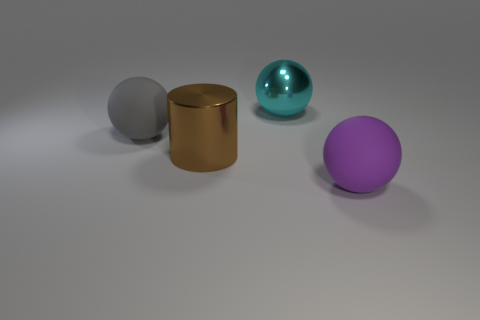There is a big rubber object that is on the right side of the large cyan metal object; how many large brown cylinders are to the left of it?
Make the answer very short. 1. Are there any purple matte objects of the same shape as the cyan metal object?
Offer a very short reply. Yes. Does the rubber thing that is to the right of the big metallic sphere have the same shape as the large rubber thing that is on the left side of the large cyan object?
Keep it short and to the point. Yes. There is a big thing that is both on the right side of the large brown metal object and left of the purple matte object; what is its shape?
Your response must be concise. Sphere. Are there any gray rubber things of the same size as the brown cylinder?
Make the answer very short. Yes. What is the material of the big gray thing?
Your answer should be very brief. Rubber. There is a large thing right of the big cyan shiny object; what color is it?
Your answer should be very brief. Purple. What number of metallic things are both behind the brown cylinder and on the left side of the large cyan metal object?
Keep it short and to the point. 0. There is a purple thing that is the same size as the gray ball; what shape is it?
Your answer should be very brief. Sphere. What material is the thing that is behind the large matte ball that is behind the large matte sphere on the right side of the cyan shiny thing made of?
Your answer should be very brief. Metal. 